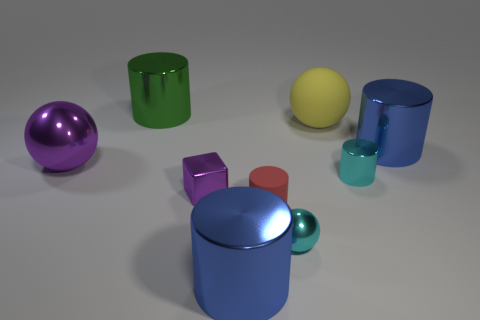Is the red thing made of the same material as the blue cylinder that is in front of the red cylinder?
Keep it short and to the point. No. Is there a cyan shiny thing in front of the tiny shiny thing to the left of the large metallic object that is in front of the cyan sphere?
Give a very brief answer. Yes. Are there any other things that are the same size as the block?
Provide a succinct answer. Yes. The tiny cylinder that is the same material as the large yellow thing is what color?
Your response must be concise. Red. What size is the metal cylinder that is left of the big yellow thing and in front of the yellow thing?
Offer a terse response. Large. Are there fewer small metallic things on the left side of the small rubber cylinder than small red objects behind the large purple object?
Give a very brief answer. No. Are the blue cylinder behind the matte cylinder and the tiny cyan object on the left side of the large rubber ball made of the same material?
Keep it short and to the point. Yes. There is a thing that is both on the left side of the small purple cube and to the right of the large shiny ball; what shape is it?
Provide a succinct answer. Cylinder. There is a big sphere that is behind the large blue shiny thing that is behind the block; what is it made of?
Offer a very short reply. Rubber. Is the number of small purple objects greater than the number of blue rubber cylinders?
Your answer should be compact. Yes. 